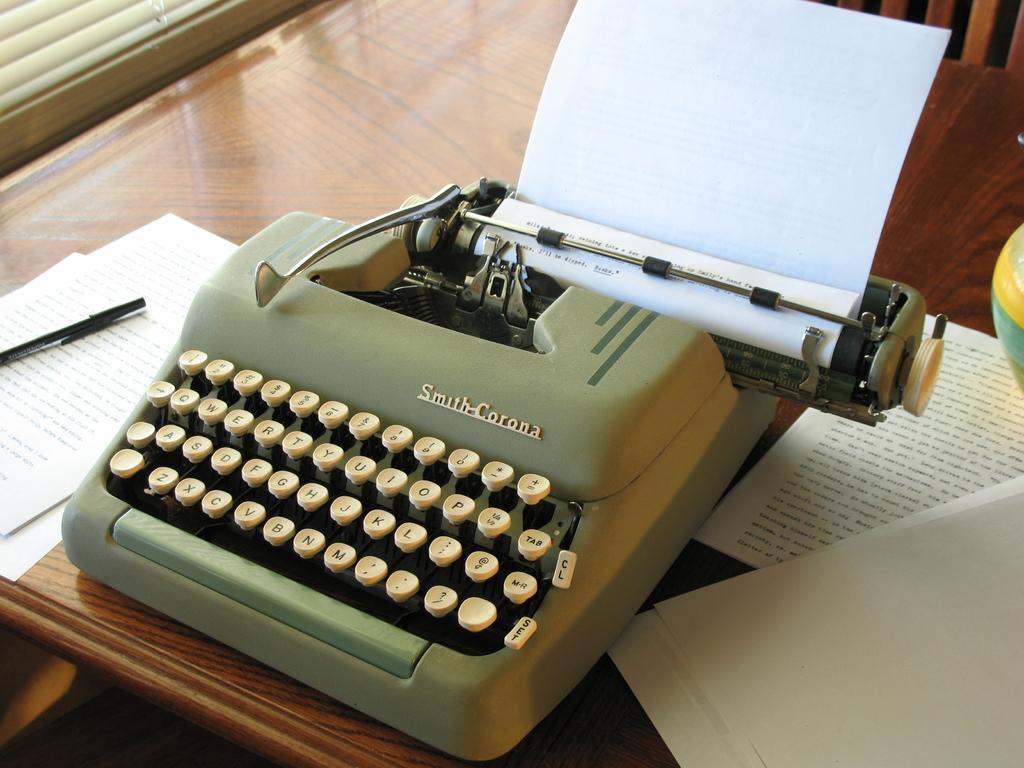What brand is the typewriter?
Make the answer very short. Smith corona. Thid typewritting machine.its used many words type in paper?
Provide a succinct answer. Unanswerable. 